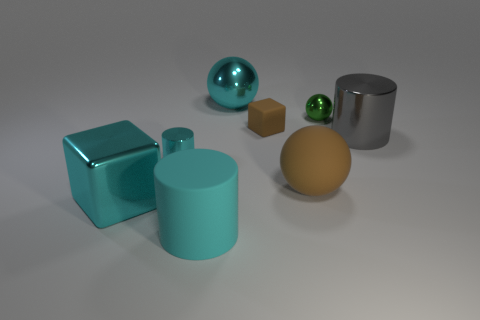Subtract all purple cubes. How many cyan cylinders are left? 2 Subtract all cyan shiny balls. How many balls are left? 2 Add 1 cylinders. How many objects exist? 9 Subtract 0 gray spheres. How many objects are left? 8 Subtract all cylinders. How many objects are left? 5 Subtract all large metal spheres. Subtract all cyan rubber objects. How many objects are left? 6 Add 1 gray cylinders. How many gray cylinders are left? 2 Add 1 big brown spheres. How many big brown spheres exist? 2 